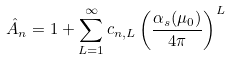Convert formula to latex. <formula><loc_0><loc_0><loc_500><loc_500>\hat { A } _ { n } = 1 + \sum _ { L = 1 } ^ { \infty } c _ { n , L } \left ( \frac { \alpha _ { s } ( \mu _ { 0 } ) } { 4 \pi } \right ) ^ { L }</formula> 